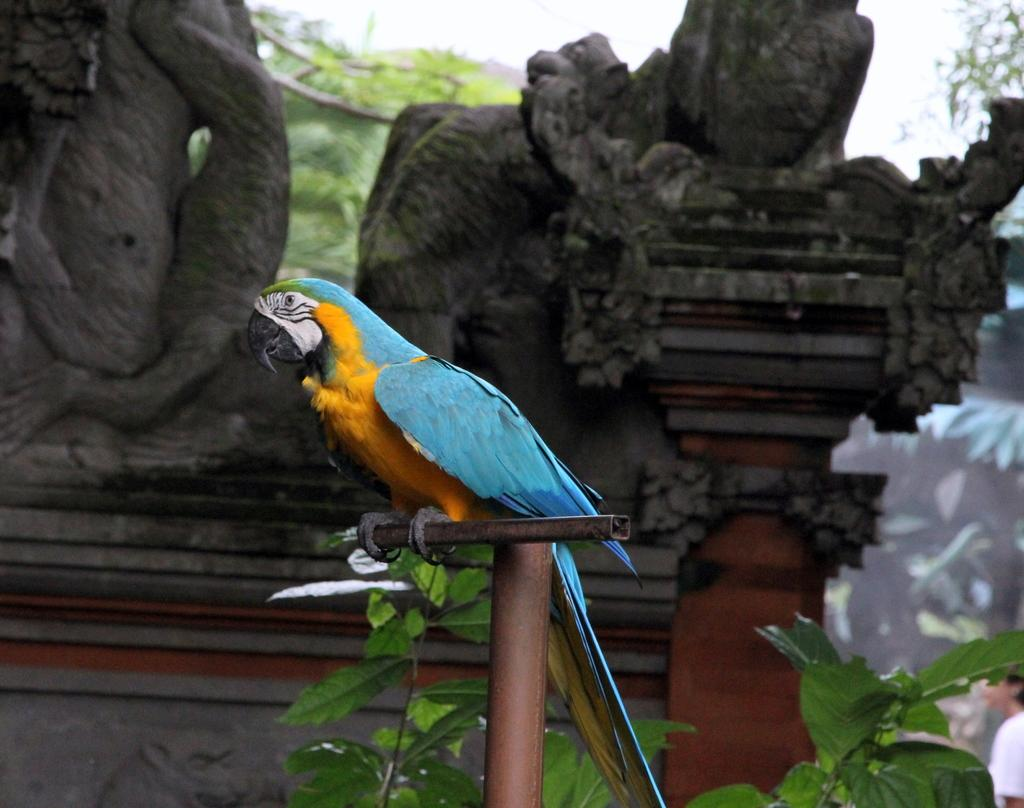What type of bird is in the front of the image? There is a macaw in the front of the image. What can be seen in the middle of the image? There are sculptures in the middle of the image. What type of vegetation is in the background of the image? There are trees in the background of the image. What is visible at the top of the image? The sky is visible at the top of the image. What type of writing can be seen on the paper in the image? There is no paper or writing present in the image. What kind of picture is hanging on the wall in the image? There is no picture hanging on the wall in the image. 